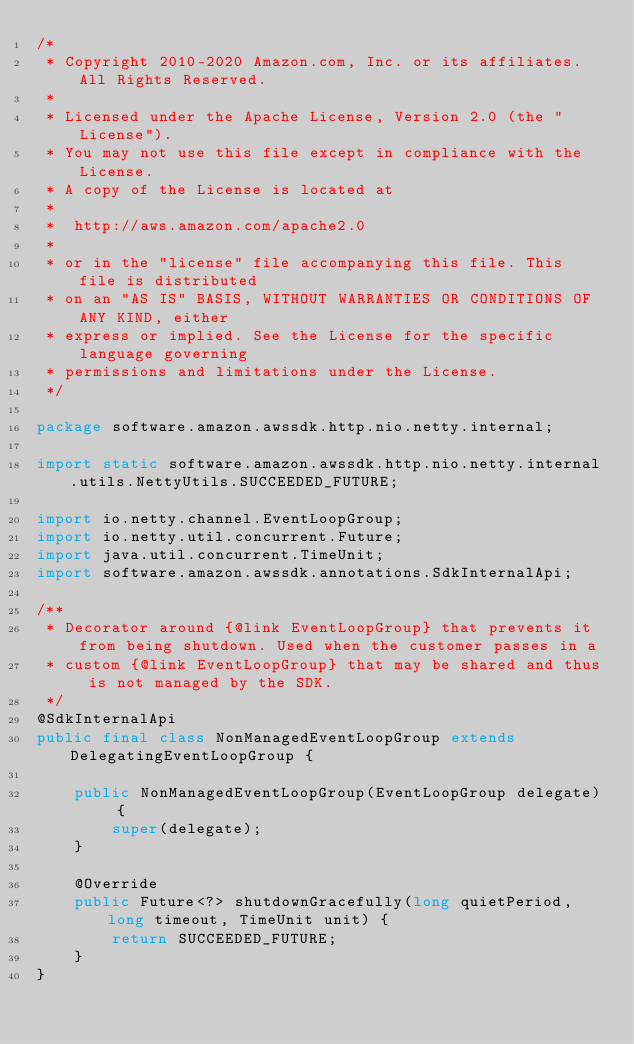<code> <loc_0><loc_0><loc_500><loc_500><_Java_>/*
 * Copyright 2010-2020 Amazon.com, Inc. or its affiliates. All Rights Reserved.
 *
 * Licensed under the Apache License, Version 2.0 (the "License").
 * You may not use this file except in compliance with the License.
 * A copy of the License is located at
 *
 *  http://aws.amazon.com/apache2.0
 *
 * or in the "license" file accompanying this file. This file is distributed
 * on an "AS IS" BASIS, WITHOUT WARRANTIES OR CONDITIONS OF ANY KIND, either
 * express or implied. See the License for the specific language governing
 * permissions and limitations under the License.
 */

package software.amazon.awssdk.http.nio.netty.internal;

import static software.amazon.awssdk.http.nio.netty.internal.utils.NettyUtils.SUCCEEDED_FUTURE;

import io.netty.channel.EventLoopGroup;
import io.netty.util.concurrent.Future;
import java.util.concurrent.TimeUnit;
import software.amazon.awssdk.annotations.SdkInternalApi;

/**
 * Decorator around {@link EventLoopGroup} that prevents it from being shutdown. Used when the customer passes in a
 * custom {@link EventLoopGroup} that may be shared and thus is not managed by the SDK.
 */
@SdkInternalApi
public final class NonManagedEventLoopGroup extends DelegatingEventLoopGroup {

    public NonManagedEventLoopGroup(EventLoopGroup delegate) {
        super(delegate);
    }

    @Override
    public Future<?> shutdownGracefully(long quietPeriod, long timeout, TimeUnit unit) {
        return SUCCEEDED_FUTURE;
    }
}
</code> 